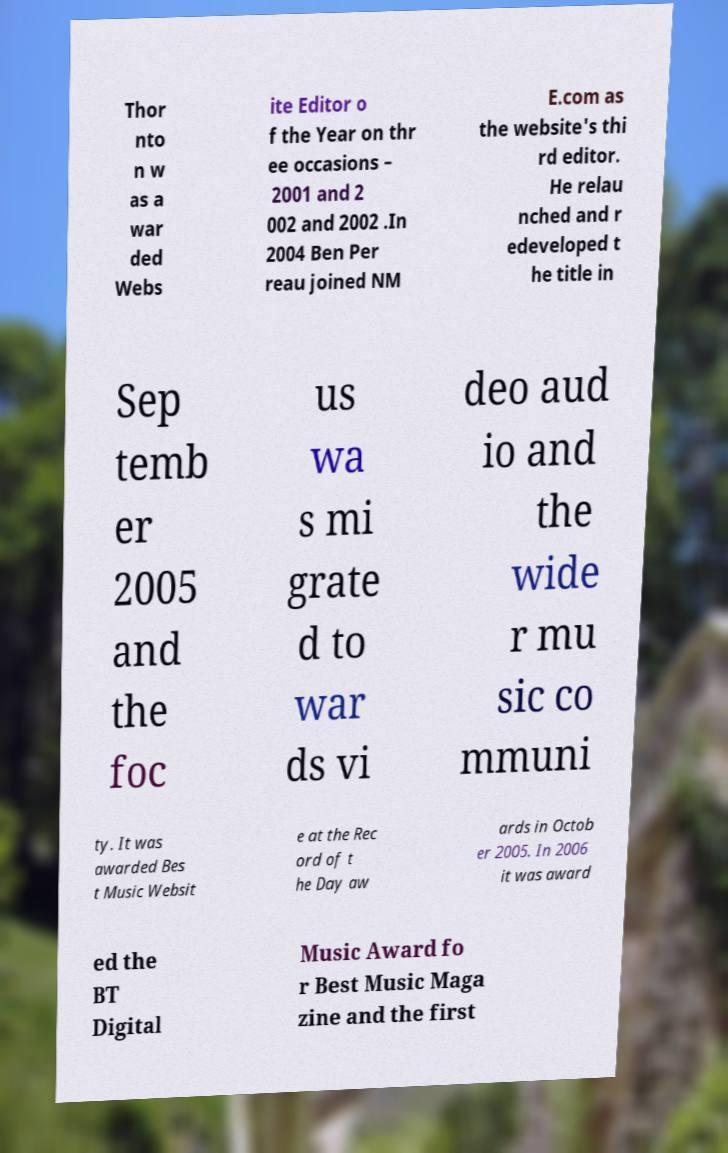What messages or text are displayed in this image? I need them in a readable, typed format. Thor nto n w as a war ded Webs ite Editor o f the Year on thr ee occasions – 2001 and 2 002 and 2002 .In 2004 Ben Per reau joined NM E.com as the website's thi rd editor. He relau nched and r edeveloped t he title in Sep temb er 2005 and the foc us wa s mi grate d to war ds vi deo aud io and the wide r mu sic co mmuni ty. It was awarded Bes t Music Websit e at the Rec ord of t he Day aw ards in Octob er 2005. In 2006 it was award ed the BT Digital Music Award fo r Best Music Maga zine and the first 